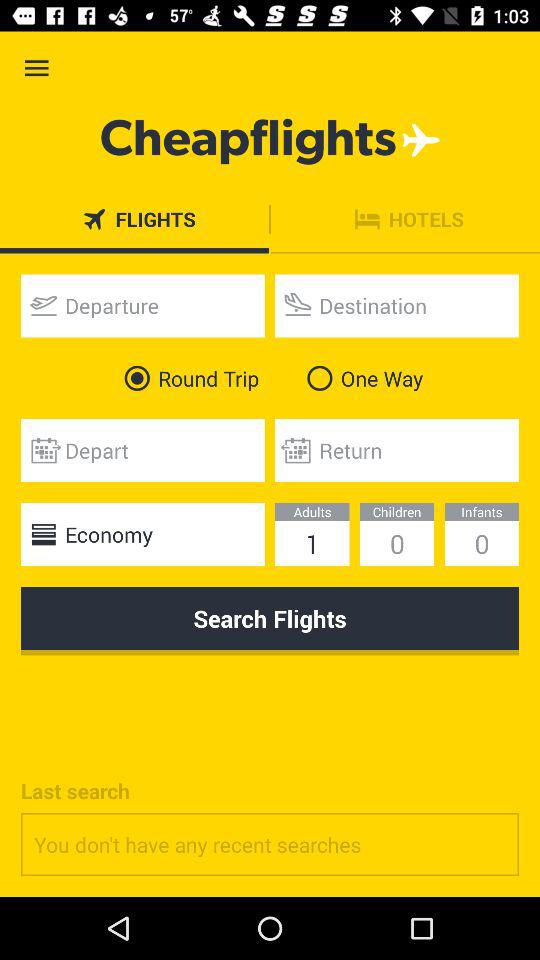How many adults are there? There is 1 adult. 